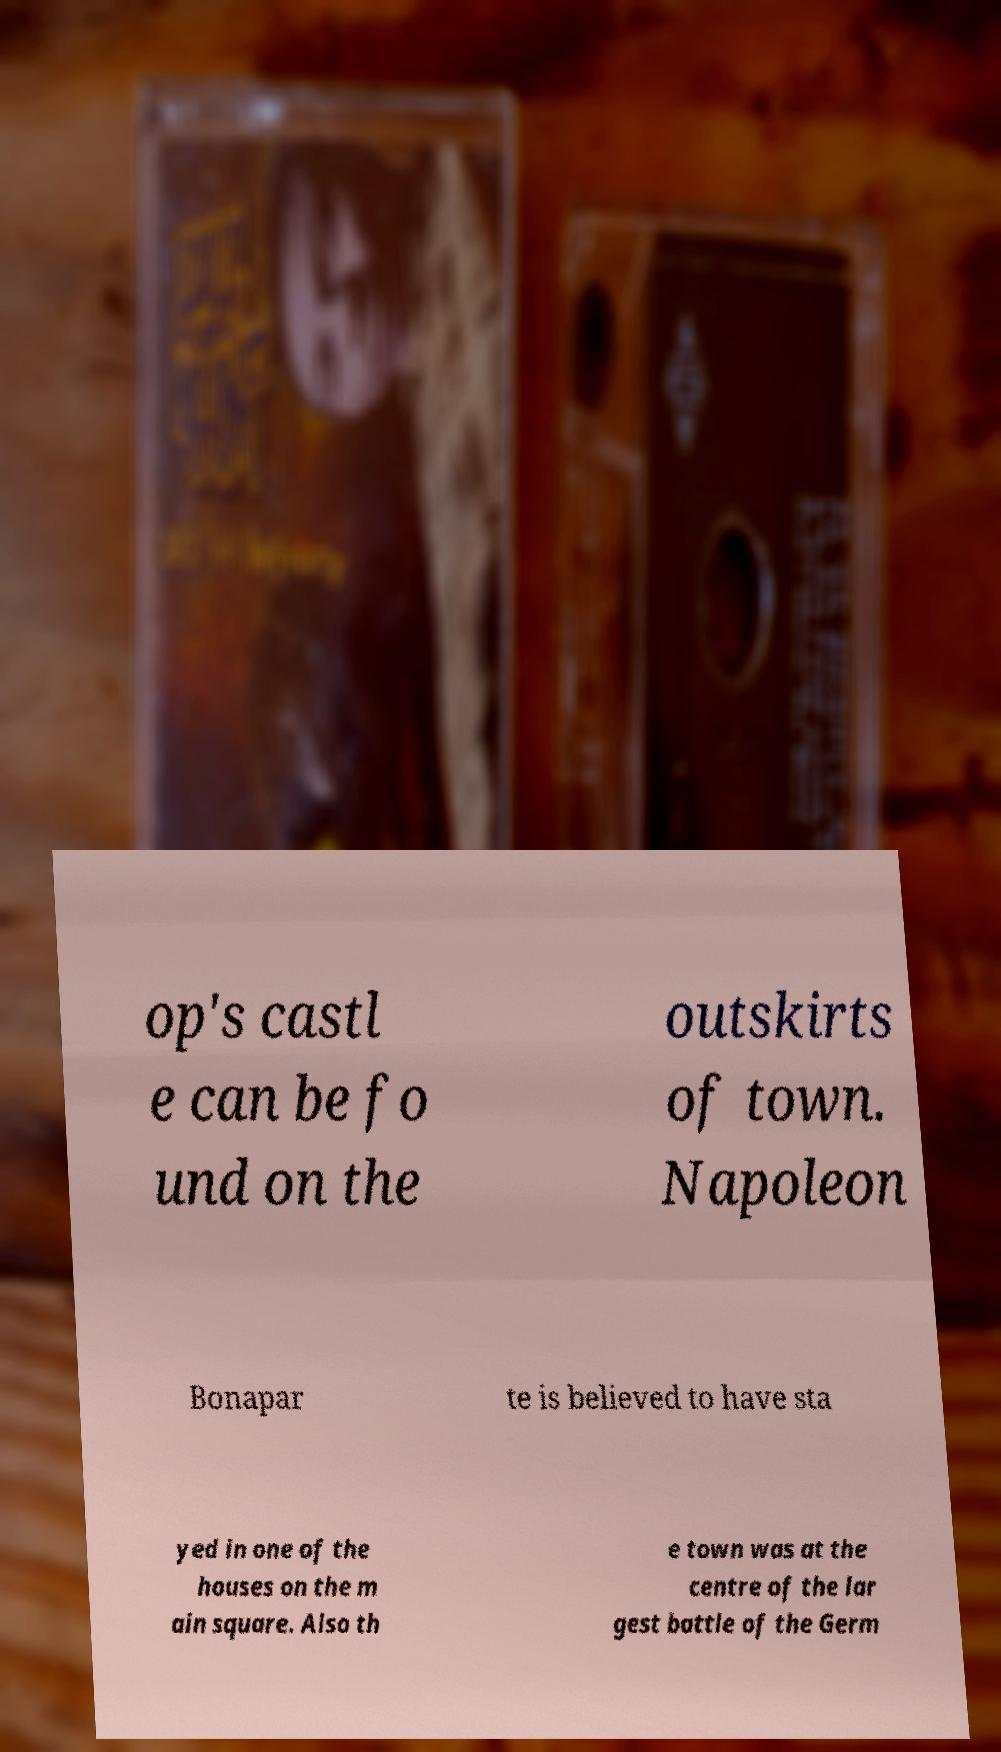Could you extract and type out the text from this image? op's castl e can be fo und on the outskirts of town. Napoleon Bonapar te is believed to have sta yed in one of the houses on the m ain square. Also th e town was at the centre of the lar gest battle of the Germ 